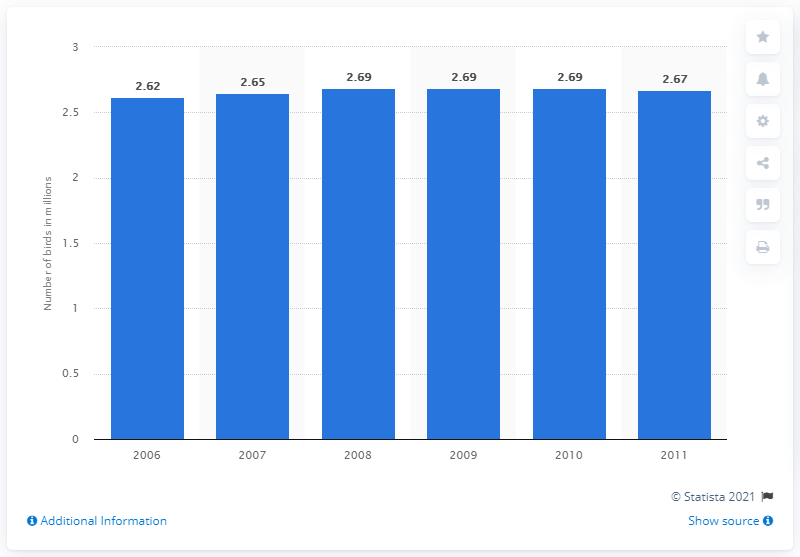Identify some key points in this picture. In 2007, approximately 2.62 million birds were owned as pets in Canada. In 2007, it is estimated that 2.67 birds were owned as pets in Canada. 